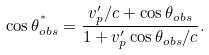Convert formula to latex. <formula><loc_0><loc_0><loc_500><loc_500>\cos { \theta _ { o b s } ^ { ^ { * } } } = \frac { v _ { p } ^ { \prime } / c + \cos { \theta _ { o b s } } } { 1 + v _ { p } ^ { \prime } \cos { \theta _ { o b s } } / c } .</formula> 